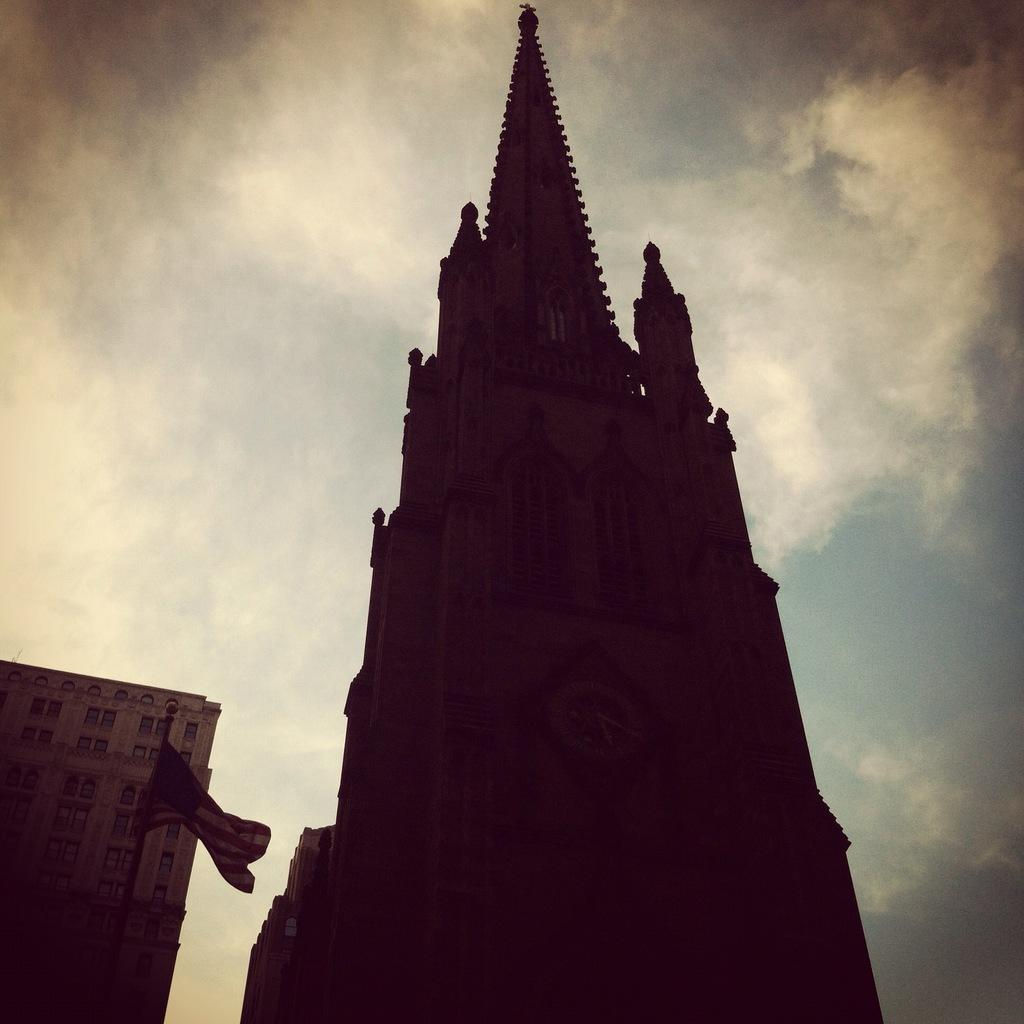What structure is located on the left side of the image? There is a building on the left side of the image. What can be seen in the image besides the building? There is a flag and a clock tower in the image. Where is the clock tower located in the image? The clock tower is in the middle of the image. What is visible at the top of the image? The sky is visible at the top of the image. Can you hear the grape laughing in the image? There is no grape present in the image, and therefore it cannot be heard laughing. Is there a bath visible in the image? There is no bath present in the image. 